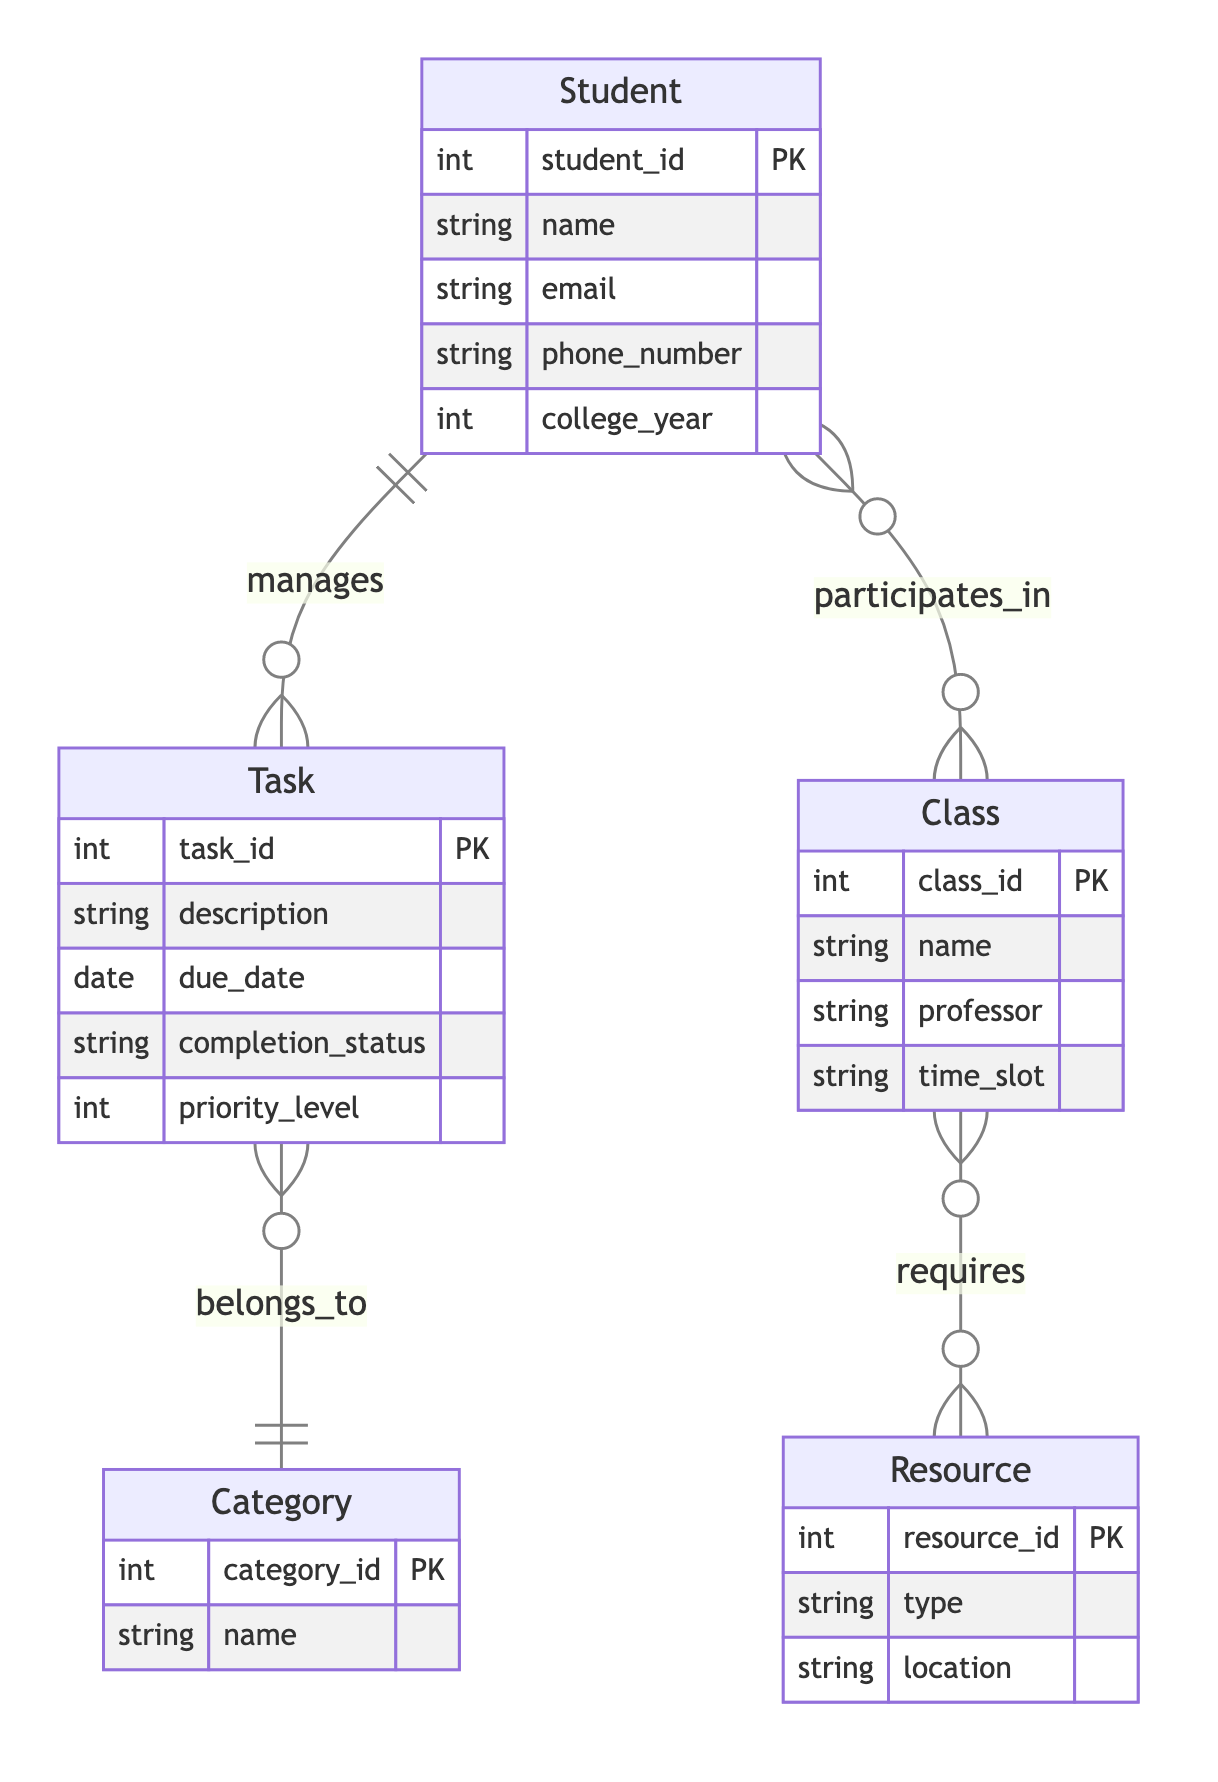What is the primary key of the Student entity? The primary key of the Student entity is the student_id attribute, which uniquely identifies each student in the database.
Answer: student_id How many attributes does the Task entity have? The Task entity has five attributes: task_id, description, due_date, completion_status, and priority_level.
Answer: 5 What relationship exists between Student and Class? There is a many-to-many relationship between Student and Class, indicated by the notation "participates_in" with a cardinality of M:N, meaning students can attend multiple classes and classes can have multiple students.
Answer: participates_in (M:N) How many relationships does the Class entity have? The Class entity has one relationship, which is "requires" with the Resource entity and has a cardinality of M:N. This indicates that each class can require multiple resources and that resources can be utilized in multiple classes.
Answer: 1 What does the Task belong to? The Task belongs to a Category entity, indicated by the relationship "belongs_to" with a cardinality of N:1, meaning many tasks can correspond to one category.
Answer: Category What is the cardinality between Task and Category? The cardinality between Task and Category is N:1, meaning many tasks can belong to one category, and each category can have multiple tasks associated with it.
Answer: N:1 Which entity requires resources? The Class entity requires resources, as shown by the relationship "requires" to the Resource entity, indicating that classes need various resources to function.
Answer: Class How many entities are represented in the diagram? There are five entities represented in the diagram: Student, Task, Category, Class, and Resource.
Answer: 5 What type of relationship exists between Class and Resource? The relationship between Class and Resource is many-to-many, indicated by the relationship "requires" with a cardinality of M:N, meaning classes can require many resources, and resources can serve multiple classes.
Answer: M:N 